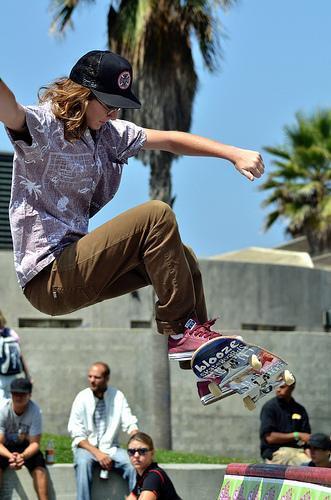How many skateboards are there?
Give a very brief answer. 1. 